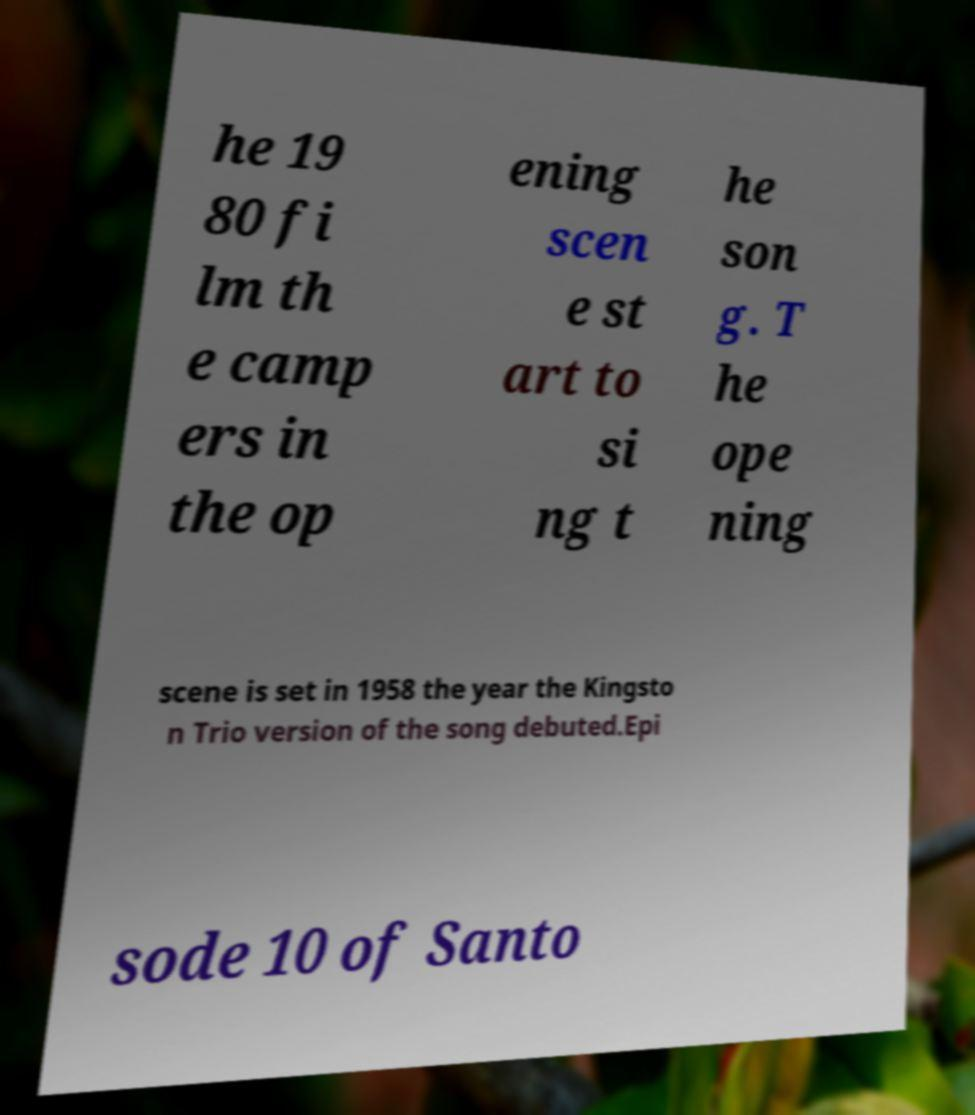Please read and relay the text visible in this image. What does it say? he 19 80 fi lm th e camp ers in the op ening scen e st art to si ng t he son g. T he ope ning scene is set in 1958 the year the Kingsto n Trio version of the song debuted.Epi sode 10 of Santo 